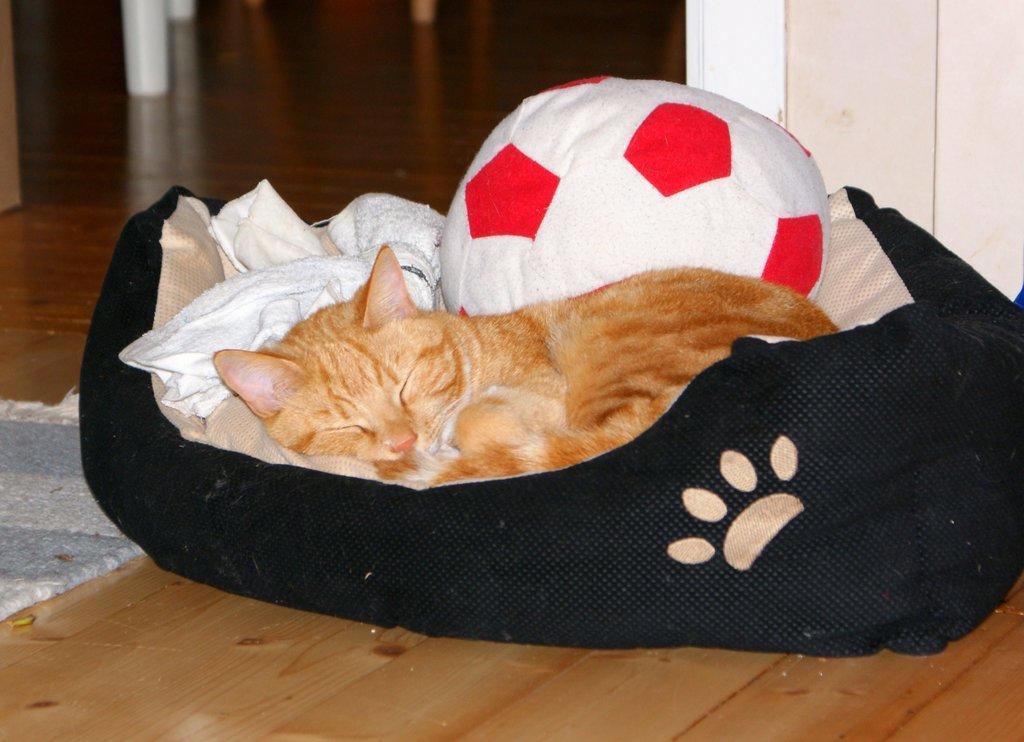Describe this image in one or two sentences. The picture consists of a bed, on the bed there are ball, cloth and a cat. On the left there is a mat. In the background we can see the legs of some objects. On the right it is well. In the foreground there is floor. 